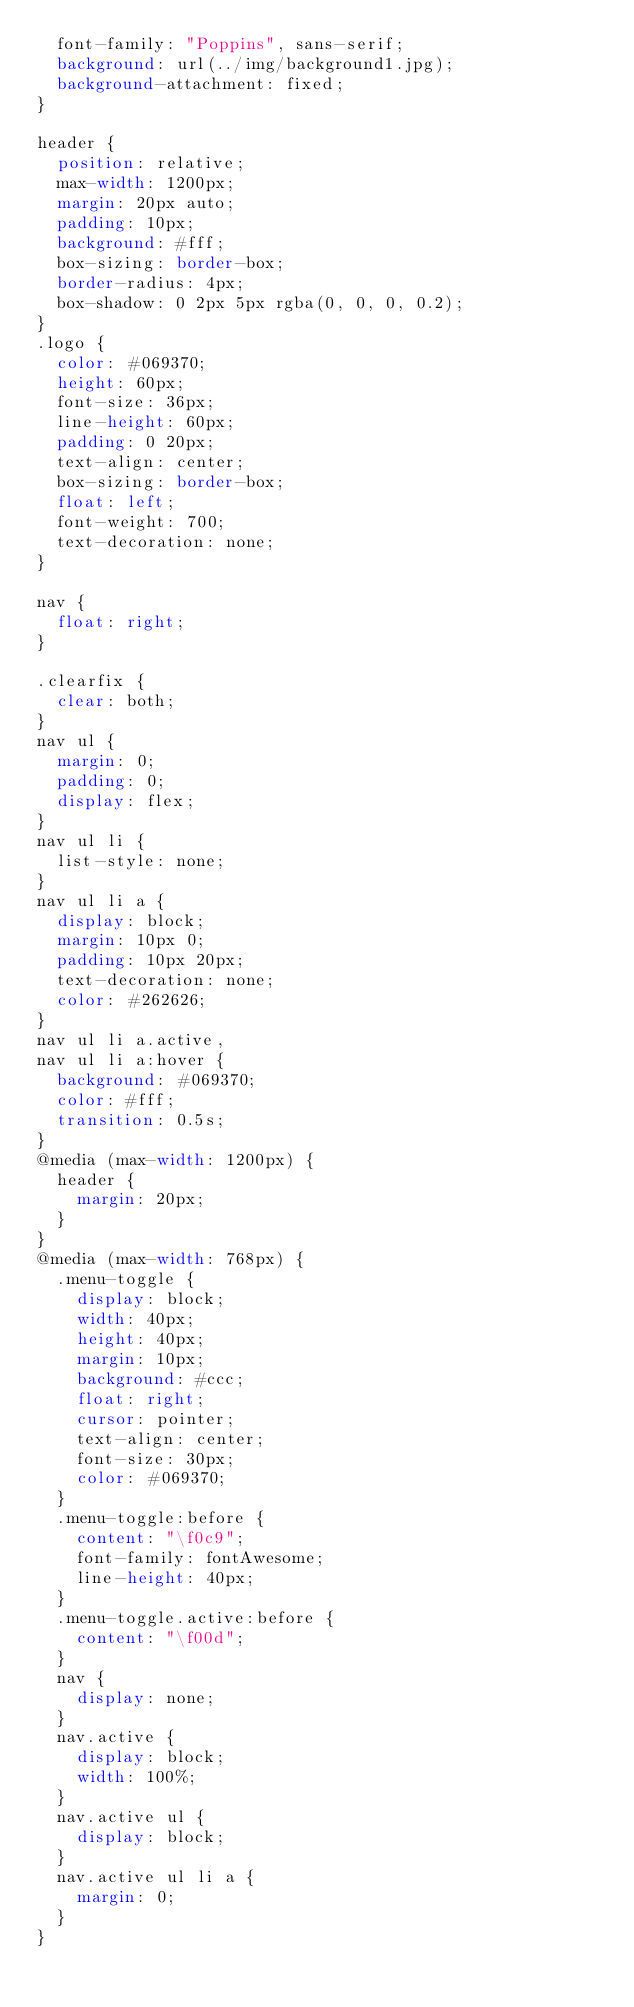<code> <loc_0><loc_0><loc_500><loc_500><_CSS_>  font-family: "Poppins", sans-serif;
  background: url(../img/background1.jpg);
  background-attachment: fixed;
}

header {
  position: relative;
  max-width: 1200px;
  margin: 20px auto;
  padding: 10px;
  background: #fff;
  box-sizing: border-box;
  border-radius: 4px;
  box-shadow: 0 2px 5px rgba(0, 0, 0, 0.2);
}
.logo {
  color: #069370;
  height: 60px;
  font-size: 36px;
  line-height: 60px;
  padding: 0 20px;
  text-align: center;
  box-sizing: border-box;
  float: left;
  font-weight: 700;
  text-decoration: none;
}

nav {
  float: right;
}

.clearfix {
  clear: both;
}
nav ul {
  margin: 0;
  padding: 0;
  display: flex;
}
nav ul li {
  list-style: none;
}
nav ul li a {
  display: block;
  margin: 10px 0;
  padding: 10px 20px;
  text-decoration: none;
  color: #262626;
}
nav ul li a.active,
nav ul li a:hover {
  background: #069370;
  color: #fff;
  transition: 0.5s;
}
@media (max-width: 1200px) {
  header {
    margin: 20px;
  }
}
@media (max-width: 768px) {
  .menu-toggle {
    display: block;
    width: 40px;
    height: 40px;
    margin: 10px;
    background: #ccc;
    float: right;
    cursor: pointer;
    text-align: center;
    font-size: 30px;
    color: #069370;
  }
  .menu-toggle:before {
    content: "\f0c9";
    font-family: fontAwesome;
    line-height: 40px;
  }
  .menu-toggle.active:before {
    content: "\f00d";
  }
  nav {
    display: none;
  }
  nav.active {
    display: block;
    width: 100%;
  }
  nav.active ul {
    display: block;
  }
  nav.active ul li a {
    margin: 0;
  }
}
</code> 